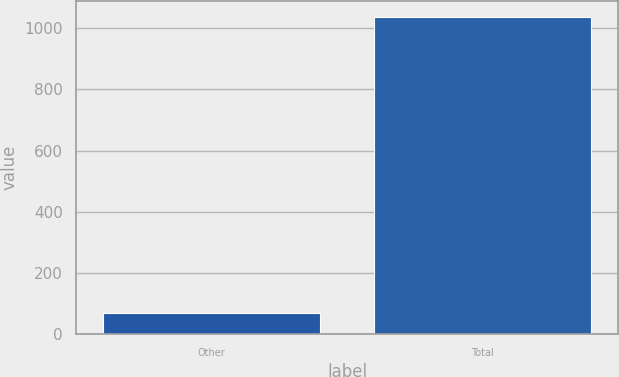<chart> <loc_0><loc_0><loc_500><loc_500><bar_chart><fcel>Other<fcel>Total<nl><fcel>69<fcel>1037<nl></chart> 